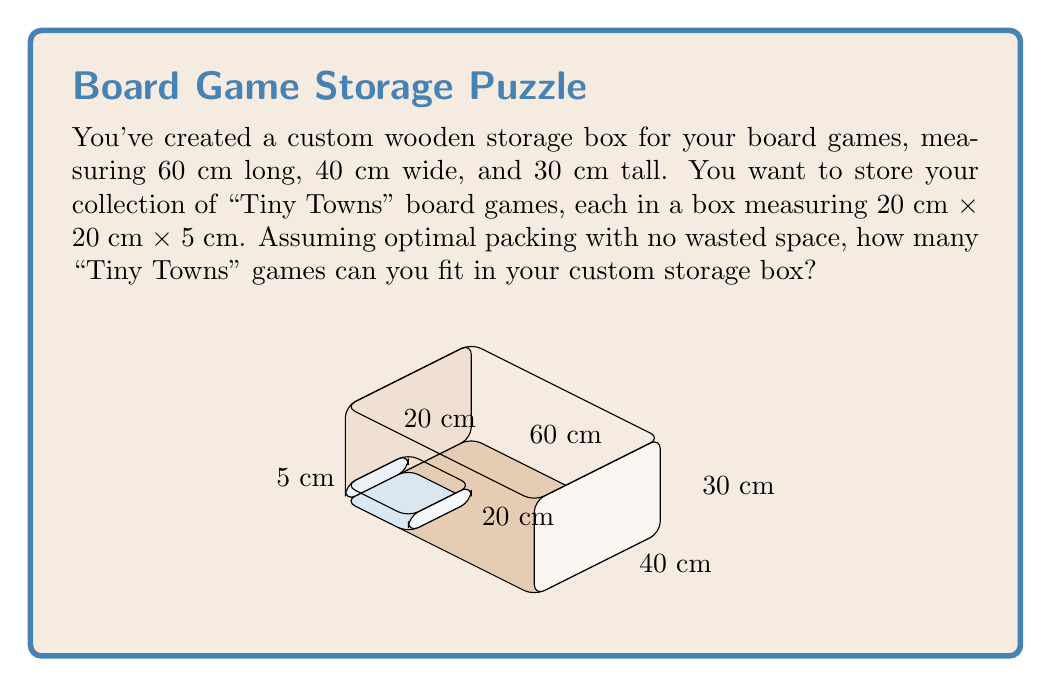Provide a solution to this math problem. To solve this problem, we need to calculate the volume of both the storage box and a single "Tiny Towns" game box, then divide the larger volume by the smaller one. Let's break it down step-by-step:

1. Calculate the volume of the custom storage box:
   $$V_{storage} = 60 \text{ cm} \times 40 \text{ cm} \times 30 \text{ cm} = 72,000 \text{ cm}^3$$

2. Calculate the volume of a single "Tiny Towns" game box:
   $$V_{game} = 20 \text{ cm} \times 20 \text{ cm} \times 5 \text{ cm} = 2,000 \text{ cm}^3$$

3. Calculate the number of games that can fit by dividing the storage volume by the game volume:
   $$N_{games} = \frac{V_{storage}}{V_{game}} = \frac{72,000 \text{ cm}^3}{2,000 \text{ cm}^3} = 36$$

Therefore, assuming optimal packing with no wasted space, you can fit 36 "Tiny Towns" game boxes in your custom storage box.

Note: In reality, there might be some small amount of wasted space due to the arrangement of the boxes, but for this calculation, we assume perfect packing.
Answer: 36 games 